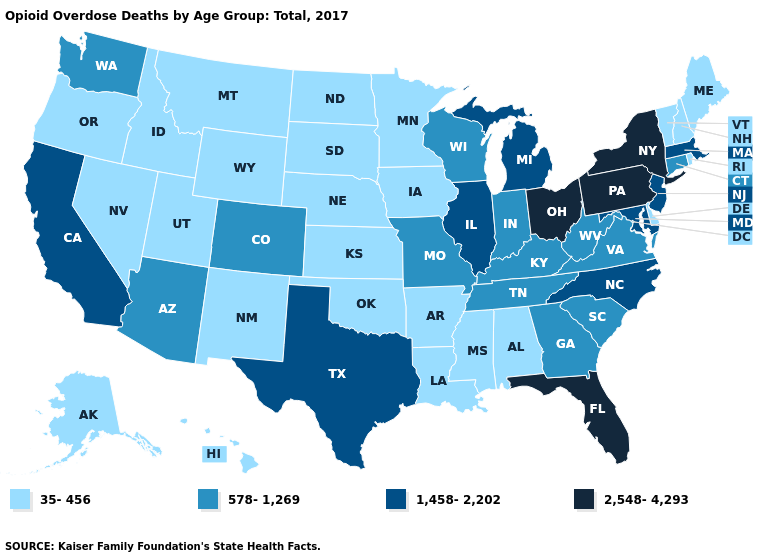Does the first symbol in the legend represent the smallest category?
Concise answer only. Yes. What is the value of New Mexico?
Be succinct. 35-456. What is the value of Iowa?
Answer briefly. 35-456. What is the value of Vermont?
Keep it brief. 35-456. Which states have the lowest value in the USA?
Concise answer only. Alabama, Alaska, Arkansas, Delaware, Hawaii, Idaho, Iowa, Kansas, Louisiana, Maine, Minnesota, Mississippi, Montana, Nebraska, Nevada, New Hampshire, New Mexico, North Dakota, Oklahoma, Oregon, Rhode Island, South Dakota, Utah, Vermont, Wyoming. Does Wyoming have the lowest value in the USA?
Concise answer only. Yes. What is the value of Pennsylvania?
Give a very brief answer. 2,548-4,293. What is the lowest value in the USA?
Keep it brief. 35-456. Among the states that border Connecticut , which have the lowest value?
Answer briefly. Rhode Island. What is the value of Florida?
Answer briefly. 2,548-4,293. Among the states that border Kentucky , which have the highest value?
Give a very brief answer. Ohio. Does California have the lowest value in the West?
Quick response, please. No. Which states have the lowest value in the USA?
Give a very brief answer. Alabama, Alaska, Arkansas, Delaware, Hawaii, Idaho, Iowa, Kansas, Louisiana, Maine, Minnesota, Mississippi, Montana, Nebraska, Nevada, New Hampshire, New Mexico, North Dakota, Oklahoma, Oregon, Rhode Island, South Dakota, Utah, Vermont, Wyoming. What is the value of Kansas?
Be succinct. 35-456. 